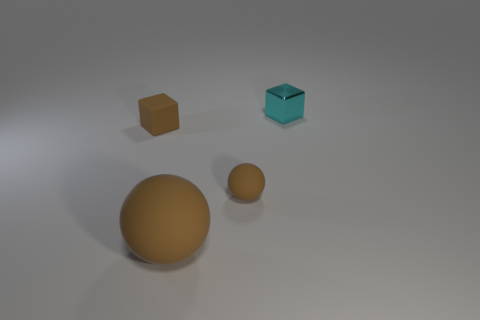There is a tiny thing that is the same color as the rubber block; what is it made of?
Ensure brevity in your answer.  Rubber. What number of rubber spheres are the same size as the cyan metal cube?
Your response must be concise. 1. What number of objects are small rubber spheres or tiny matte objects that are in front of the small rubber cube?
Keep it short and to the point. 1. The cyan thing has what shape?
Your response must be concise. Cube. Does the rubber block have the same color as the large ball?
Offer a very short reply. Yes. The ball that is the same size as the metallic thing is what color?
Give a very brief answer. Brown. How many brown objects are either blocks or tiny objects?
Make the answer very short. 2. Are there more cyan metallic things than big yellow blocks?
Your answer should be compact. Yes. Is the size of the matte thing that is on the left side of the big brown matte object the same as the ball on the left side of the small sphere?
Offer a terse response. No. There is a cube in front of the tiny thing that is behind the tiny block that is in front of the cyan thing; what color is it?
Ensure brevity in your answer.  Brown. 